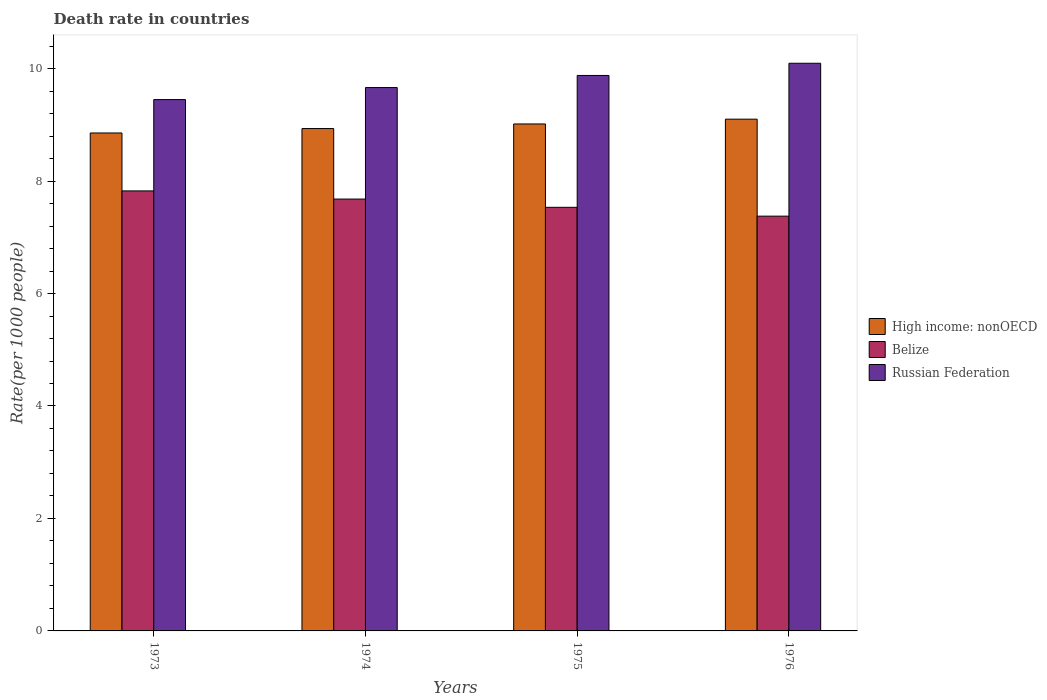How many different coloured bars are there?
Provide a succinct answer. 3. How many groups of bars are there?
Give a very brief answer. 4. How many bars are there on the 1st tick from the left?
Keep it short and to the point. 3. How many bars are there on the 4th tick from the right?
Make the answer very short. 3. What is the label of the 2nd group of bars from the left?
Your answer should be compact. 1974. What is the death rate in Belize in 1974?
Provide a succinct answer. 7.68. Across all years, what is the maximum death rate in Belize?
Give a very brief answer. 7.83. Across all years, what is the minimum death rate in High income: nonOECD?
Ensure brevity in your answer.  8.86. In which year was the death rate in High income: nonOECD maximum?
Provide a short and direct response. 1976. In which year was the death rate in Russian Federation minimum?
Keep it short and to the point. 1973. What is the total death rate in Belize in the graph?
Ensure brevity in your answer.  30.41. What is the difference between the death rate in High income: nonOECD in 1973 and that in 1975?
Your answer should be compact. -0.16. What is the difference between the death rate in Belize in 1973 and the death rate in Russian Federation in 1974?
Your answer should be compact. -1.84. What is the average death rate in High income: nonOECD per year?
Keep it short and to the point. 8.98. In the year 1974, what is the difference between the death rate in Belize and death rate in Russian Federation?
Offer a very short reply. -1.98. In how many years, is the death rate in Belize greater than 4.8?
Your answer should be compact. 4. What is the ratio of the death rate in Belize in 1974 to that in 1976?
Your answer should be very brief. 1.04. Is the death rate in Belize in 1974 less than that in 1976?
Your answer should be very brief. No. Is the difference between the death rate in Belize in 1973 and 1975 greater than the difference between the death rate in Russian Federation in 1973 and 1975?
Give a very brief answer. Yes. What is the difference between the highest and the second highest death rate in Russian Federation?
Keep it short and to the point. 0.22. What is the difference between the highest and the lowest death rate in Russian Federation?
Your answer should be compact. 0.65. What does the 2nd bar from the left in 1975 represents?
Offer a very short reply. Belize. What does the 1st bar from the right in 1973 represents?
Offer a very short reply. Russian Federation. Is it the case that in every year, the sum of the death rate in High income: nonOECD and death rate in Russian Federation is greater than the death rate in Belize?
Give a very brief answer. Yes. Are all the bars in the graph horizontal?
Offer a very short reply. No. How many years are there in the graph?
Make the answer very short. 4. Are the values on the major ticks of Y-axis written in scientific E-notation?
Provide a succinct answer. No. Does the graph contain grids?
Provide a short and direct response. No. Where does the legend appear in the graph?
Your response must be concise. Center right. How are the legend labels stacked?
Offer a very short reply. Vertical. What is the title of the graph?
Provide a short and direct response. Death rate in countries. What is the label or title of the X-axis?
Your response must be concise. Years. What is the label or title of the Y-axis?
Offer a terse response. Rate(per 1000 people). What is the Rate(per 1000 people) of High income: nonOECD in 1973?
Your answer should be compact. 8.86. What is the Rate(per 1000 people) of Belize in 1973?
Your answer should be compact. 7.83. What is the Rate(per 1000 people) in Russian Federation in 1973?
Offer a very short reply. 9.45. What is the Rate(per 1000 people) in High income: nonOECD in 1974?
Your answer should be very brief. 8.93. What is the Rate(per 1000 people) in Belize in 1974?
Make the answer very short. 7.68. What is the Rate(per 1000 people) in Russian Federation in 1974?
Your answer should be very brief. 9.66. What is the Rate(per 1000 people) of High income: nonOECD in 1975?
Your response must be concise. 9.02. What is the Rate(per 1000 people) of Belize in 1975?
Provide a succinct answer. 7.53. What is the Rate(per 1000 people) of Russian Federation in 1975?
Your response must be concise. 9.88. What is the Rate(per 1000 people) of High income: nonOECD in 1976?
Give a very brief answer. 9.1. What is the Rate(per 1000 people) in Belize in 1976?
Keep it short and to the point. 7.38. What is the Rate(per 1000 people) in Russian Federation in 1976?
Offer a very short reply. 10.1. Across all years, what is the maximum Rate(per 1000 people) in High income: nonOECD?
Provide a short and direct response. 9.1. Across all years, what is the maximum Rate(per 1000 people) in Belize?
Give a very brief answer. 7.83. Across all years, what is the maximum Rate(per 1000 people) in Russian Federation?
Make the answer very short. 10.1. Across all years, what is the minimum Rate(per 1000 people) in High income: nonOECD?
Give a very brief answer. 8.86. Across all years, what is the minimum Rate(per 1000 people) in Belize?
Your answer should be compact. 7.38. Across all years, what is the minimum Rate(per 1000 people) of Russian Federation?
Provide a short and direct response. 9.45. What is the total Rate(per 1000 people) in High income: nonOECD in the graph?
Offer a very short reply. 35.91. What is the total Rate(per 1000 people) of Belize in the graph?
Provide a short and direct response. 30.41. What is the total Rate(per 1000 people) in Russian Federation in the graph?
Ensure brevity in your answer.  39.09. What is the difference between the Rate(per 1000 people) of High income: nonOECD in 1973 and that in 1974?
Offer a terse response. -0.08. What is the difference between the Rate(per 1000 people) of Belize in 1973 and that in 1974?
Make the answer very short. 0.14. What is the difference between the Rate(per 1000 people) of Russian Federation in 1973 and that in 1974?
Offer a terse response. -0.21. What is the difference between the Rate(per 1000 people) in High income: nonOECD in 1973 and that in 1975?
Offer a very short reply. -0.16. What is the difference between the Rate(per 1000 people) of Belize in 1973 and that in 1975?
Keep it short and to the point. 0.29. What is the difference between the Rate(per 1000 people) in Russian Federation in 1973 and that in 1975?
Give a very brief answer. -0.43. What is the difference between the Rate(per 1000 people) in High income: nonOECD in 1973 and that in 1976?
Your answer should be very brief. -0.25. What is the difference between the Rate(per 1000 people) in Belize in 1973 and that in 1976?
Provide a short and direct response. 0.45. What is the difference between the Rate(per 1000 people) of Russian Federation in 1973 and that in 1976?
Keep it short and to the point. -0.65. What is the difference between the Rate(per 1000 people) of High income: nonOECD in 1974 and that in 1975?
Ensure brevity in your answer.  -0.08. What is the difference between the Rate(per 1000 people) in Belize in 1974 and that in 1975?
Make the answer very short. 0.15. What is the difference between the Rate(per 1000 people) in Russian Federation in 1974 and that in 1975?
Your answer should be very brief. -0.21. What is the difference between the Rate(per 1000 people) of High income: nonOECD in 1974 and that in 1976?
Offer a very short reply. -0.17. What is the difference between the Rate(per 1000 people) of Belize in 1974 and that in 1976?
Offer a terse response. 0.3. What is the difference between the Rate(per 1000 people) in Russian Federation in 1974 and that in 1976?
Your answer should be very brief. -0.43. What is the difference between the Rate(per 1000 people) of High income: nonOECD in 1975 and that in 1976?
Your response must be concise. -0.09. What is the difference between the Rate(per 1000 people) of Belize in 1975 and that in 1976?
Offer a very short reply. 0.16. What is the difference between the Rate(per 1000 people) of Russian Federation in 1975 and that in 1976?
Your answer should be very brief. -0.22. What is the difference between the Rate(per 1000 people) of High income: nonOECD in 1973 and the Rate(per 1000 people) of Belize in 1974?
Make the answer very short. 1.18. What is the difference between the Rate(per 1000 people) in High income: nonOECD in 1973 and the Rate(per 1000 people) in Russian Federation in 1974?
Make the answer very short. -0.81. What is the difference between the Rate(per 1000 people) in Belize in 1973 and the Rate(per 1000 people) in Russian Federation in 1974?
Make the answer very short. -1.84. What is the difference between the Rate(per 1000 people) of High income: nonOECD in 1973 and the Rate(per 1000 people) of Belize in 1975?
Make the answer very short. 1.32. What is the difference between the Rate(per 1000 people) in High income: nonOECD in 1973 and the Rate(per 1000 people) in Russian Federation in 1975?
Offer a terse response. -1.02. What is the difference between the Rate(per 1000 people) of Belize in 1973 and the Rate(per 1000 people) of Russian Federation in 1975?
Give a very brief answer. -2.05. What is the difference between the Rate(per 1000 people) in High income: nonOECD in 1973 and the Rate(per 1000 people) in Belize in 1976?
Your answer should be compact. 1.48. What is the difference between the Rate(per 1000 people) of High income: nonOECD in 1973 and the Rate(per 1000 people) of Russian Federation in 1976?
Your response must be concise. -1.24. What is the difference between the Rate(per 1000 people) of Belize in 1973 and the Rate(per 1000 people) of Russian Federation in 1976?
Your answer should be compact. -2.27. What is the difference between the Rate(per 1000 people) of High income: nonOECD in 1974 and the Rate(per 1000 people) of Belize in 1975?
Offer a very short reply. 1.4. What is the difference between the Rate(per 1000 people) in High income: nonOECD in 1974 and the Rate(per 1000 people) in Russian Federation in 1975?
Offer a very short reply. -0.94. What is the difference between the Rate(per 1000 people) in Belize in 1974 and the Rate(per 1000 people) in Russian Federation in 1975?
Offer a very short reply. -2.2. What is the difference between the Rate(per 1000 people) of High income: nonOECD in 1974 and the Rate(per 1000 people) of Belize in 1976?
Your answer should be compact. 1.56. What is the difference between the Rate(per 1000 people) in High income: nonOECD in 1974 and the Rate(per 1000 people) in Russian Federation in 1976?
Make the answer very short. -1.16. What is the difference between the Rate(per 1000 people) in Belize in 1974 and the Rate(per 1000 people) in Russian Federation in 1976?
Offer a very short reply. -2.42. What is the difference between the Rate(per 1000 people) of High income: nonOECD in 1975 and the Rate(per 1000 people) of Belize in 1976?
Your response must be concise. 1.64. What is the difference between the Rate(per 1000 people) of High income: nonOECD in 1975 and the Rate(per 1000 people) of Russian Federation in 1976?
Keep it short and to the point. -1.08. What is the difference between the Rate(per 1000 people) in Belize in 1975 and the Rate(per 1000 people) in Russian Federation in 1976?
Keep it short and to the point. -2.56. What is the average Rate(per 1000 people) of High income: nonOECD per year?
Offer a very short reply. 8.98. What is the average Rate(per 1000 people) of Belize per year?
Provide a succinct answer. 7.6. What is the average Rate(per 1000 people) in Russian Federation per year?
Provide a short and direct response. 9.77. In the year 1973, what is the difference between the Rate(per 1000 people) in High income: nonOECD and Rate(per 1000 people) in Belize?
Ensure brevity in your answer.  1.03. In the year 1973, what is the difference between the Rate(per 1000 people) of High income: nonOECD and Rate(per 1000 people) of Russian Federation?
Your answer should be compact. -0.59. In the year 1973, what is the difference between the Rate(per 1000 people) of Belize and Rate(per 1000 people) of Russian Federation?
Keep it short and to the point. -1.62. In the year 1974, what is the difference between the Rate(per 1000 people) of High income: nonOECD and Rate(per 1000 people) of Belize?
Ensure brevity in your answer.  1.25. In the year 1974, what is the difference between the Rate(per 1000 people) of High income: nonOECD and Rate(per 1000 people) of Russian Federation?
Keep it short and to the point. -0.73. In the year 1974, what is the difference between the Rate(per 1000 people) of Belize and Rate(per 1000 people) of Russian Federation?
Your answer should be compact. -1.98. In the year 1975, what is the difference between the Rate(per 1000 people) in High income: nonOECD and Rate(per 1000 people) in Belize?
Offer a very short reply. 1.48. In the year 1975, what is the difference between the Rate(per 1000 people) of High income: nonOECD and Rate(per 1000 people) of Russian Federation?
Provide a short and direct response. -0.86. In the year 1975, what is the difference between the Rate(per 1000 people) in Belize and Rate(per 1000 people) in Russian Federation?
Keep it short and to the point. -2.35. In the year 1976, what is the difference between the Rate(per 1000 people) of High income: nonOECD and Rate(per 1000 people) of Belize?
Provide a short and direct response. 1.72. In the year 1976, what is the difference between the Rate(per 1000 people) of High income: nonOECD and Rate(per 1000 people) of Russian Federation?
Offer a very short reply. -0.99. In the year 1976, what is the difference between the Rate(per 1000 people) of Belize and Rate(per 1000 people) of Russian Federation?
Keep it short and to the point. -2.72. What is the ratio of the Rate(per 1000 people) of High income: nonOECD in 1973 to that in 1974?
Give a very brief answer. 0.99. What is the ratio of the Rate(per 1000 people) of Belize in 1973 to that in 1974?
Offer a terse response. 1.02. What is the ratio of the Rate(per 1000 people) in Russian Federation in 1973 to that in 1974?
Make the answer very short. 0.98. What is the ratio of the Rate(per 1000 people) in High income: nonOECD in 1973 to that in 1975?
Offer a terse response. 0.98. What is the ratio of the Rate(per 1000 people) of Belize in 1973 to that in 1975?
Ensure brevity in your answer.  1.04. What is the ratio of the Rate(per 1000 people) of Russian Federation in 1973 to that in 1975?
Your answer should be compact. 0.96. What is the ratio of the Rate(per 1000 people) of Belize in 1973 to that in 1976?
Provide a short and direct response. 1.06. What is the ratio of the Rate(per 1000 people) of Russian Federation in 1973 to that in 1976?
Keep it short and to the point. 0.94. What is the ratio of the Rate(per 1000 people) of High income: nonOECD in 1974 to that in 1975?
Ensure brevity in your answer.  0.99. What is the ratio of the Rate(per 1000 people) of Belize in 1974 to that in 1975?
Your response must be concise. 1.02. What is the ratio of the Rate(per 1000 people) of Russian Federation in 1974 to that in 1975?
Your answer should be very brief. 0.98. What is the ratio of the Rate(per 1000 people) of High income: nonOECD in 1974 to that in 1976?
Keep it short and to the point. 0.98. What is the ratio of the Rate(per 1000 people) in Belize in 1974 to that in 1976?
Ensure brevity in your answer.  1.04. What is the ratio of the Rate(per 1000 people) in Russian Federation in 1974 to that in 1976?
Your answer should be compact. 0.96. What is the ratio of the Rate(per 1000 people) of High income: nonOECD in 1975 to that in 1976?
Provide a short and direct response. 0.99. What is the ratio of the Rate(per 1000 people) of Belize in 1975 to that in 1976?
Make the answer very short. 1.02. What is the ratio of the Rate(per 1000 people) in Russian Federation in 1975 to that in 1976?
Your response must be concise. 0.98. What is the difference between the highest and the second highest Rate(per 1000 people) in High income: nonOECD?
Make the answer very short. 0.09. What is the difference between the highest and the second highest Rate(per 1000 people) of Belize?
Your response must be concise. 0.14. What is the difference between the highest and the second highest Rate(per 1000 people) of Russian Federation?
Provide a short and direct response. 0.22. What is the difference between the highest and the lowest Rate(per 1000 people) in High income: nonOECD?
Your answer should be very brief. 0.25. What is the difference between the highest and the lowest Rate(per 1000 people) of Belize?
Your answer should be compact. 0.45. What is the difference between the highest and the lowest Rate(per 1000 people) in Russian Federation?
Make the answer very short. 0.65. 